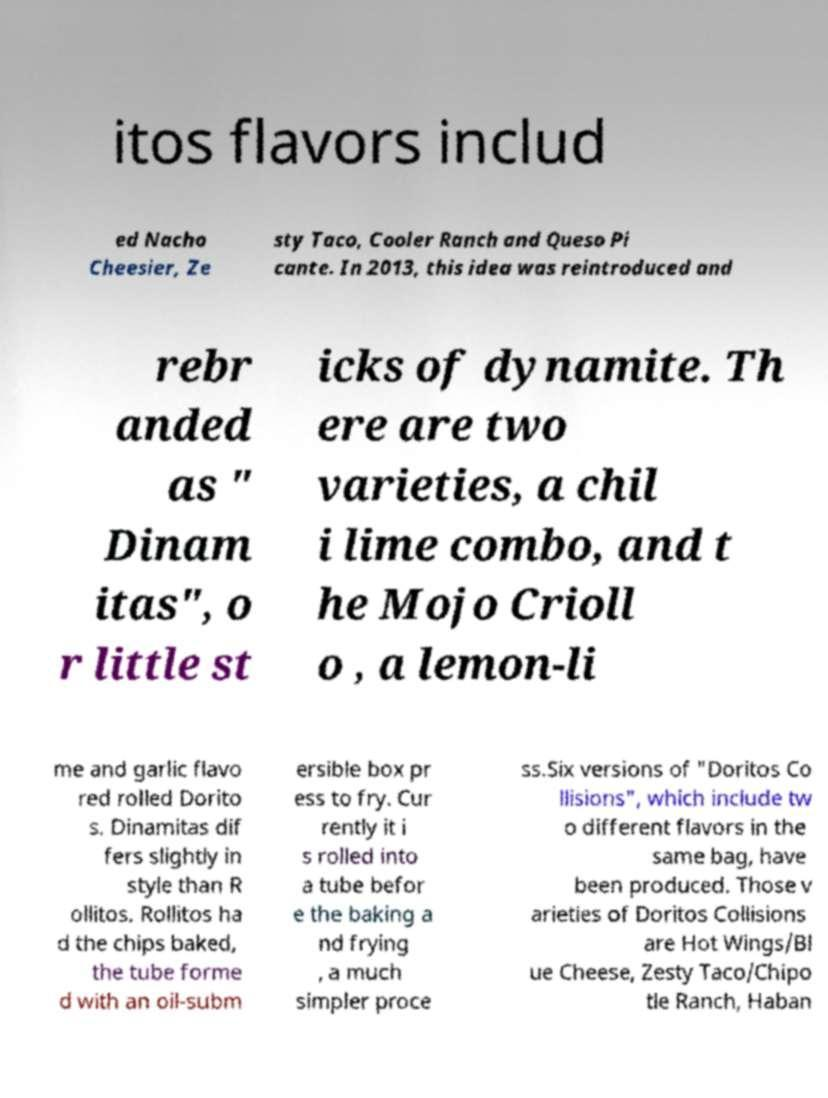Can you read and provide the text displayed in the image?This photo seems to have some interesting text. Can you extract and type it out for me? itos flavors includ ed Nacho Cheesier, Ze sty Taco, Cooler Ranch and Queso Pi cante. In 2013, this idea was reintroduced and rebr anded as " Dinam itas", o r little st icks of dynamite. Th ere are two varieties, a chil i lime combo, and t he Mojo Crioll o , a lemon-li me and garlic flavo red rolled Dorito s. Dinamitas dif fers slightly in style than R ollitos. Rollitos ha d the chips baked, the tube forme d with an oil-subm ersible box pr ess to fry. Cur rently it i s rolled into a tube befor e the baking a nd frying , a much simpler proce ss.Six versions of "Doritos Co llisions", which include tw o different flavors in the same bag, have been produced. Those v arieties of Doritos Collisions are Hot Wings/Bl ue Cheese, Zesty Taco/Chipo tle Ranch, Haban 